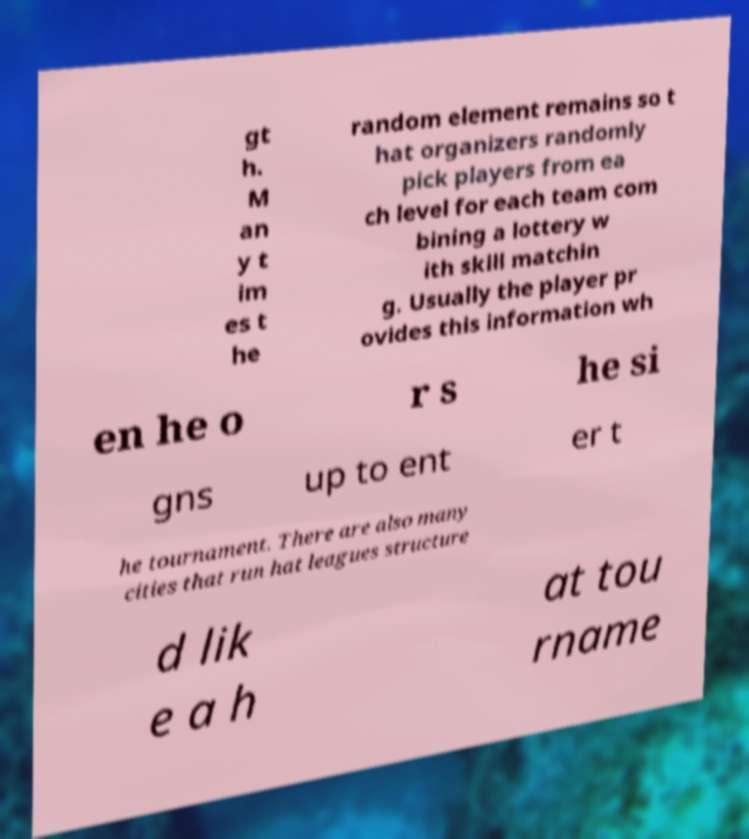Could you extract and type out the text from this image? gt h. M an y t im es t he random element remains so t hat organizers randomly pick players from ea ch level for each team com bining a lottery w ith skill matchin g. Usually the player pr ovides this information wh en he o r s he si gns up to ent er t he tournament. There are also many cities that run hat leagues structure d lik e a h at tou rname 